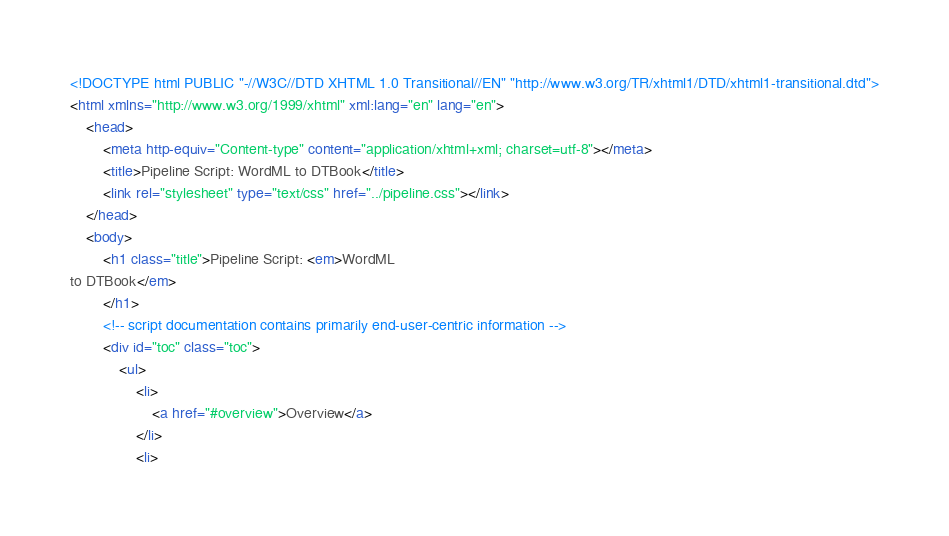Convert code to text. <code><loc_0><loc_0><loc_500><loc_500><_HTML_><!DOCTYPE html PUBLIC "-//W3C//DTD XHTML 1.0 Transitional//EN" "http://www.w3.org/TR/xhtml1/DTD/xhtml1-transitional.dtd">
<html xmlns="http://www.w3.org/1999/xhtml" xml:lang="en" lang="en">
	<head>
		<meta http-equiv="Content-type" content="application/xhtml+xml; charset=utf-8"></meta>
		<title>Pipeline Script: WordML to DTBook</title>
		<link rel="stylesheet" type="text/css" href="../pipeline.css"></link>
	</head>
	<body>
		<h1 class="title">Pipeline Script: <em>WordML
to DTBook</em>
		</h1>
		<!-- script documentation contains primarily end-user-centric information -->
		<div id="toc" class="toc">
			<ul>
				<li>
					<a href="#overview">Overview</a>
				</li>
				<li></code> 